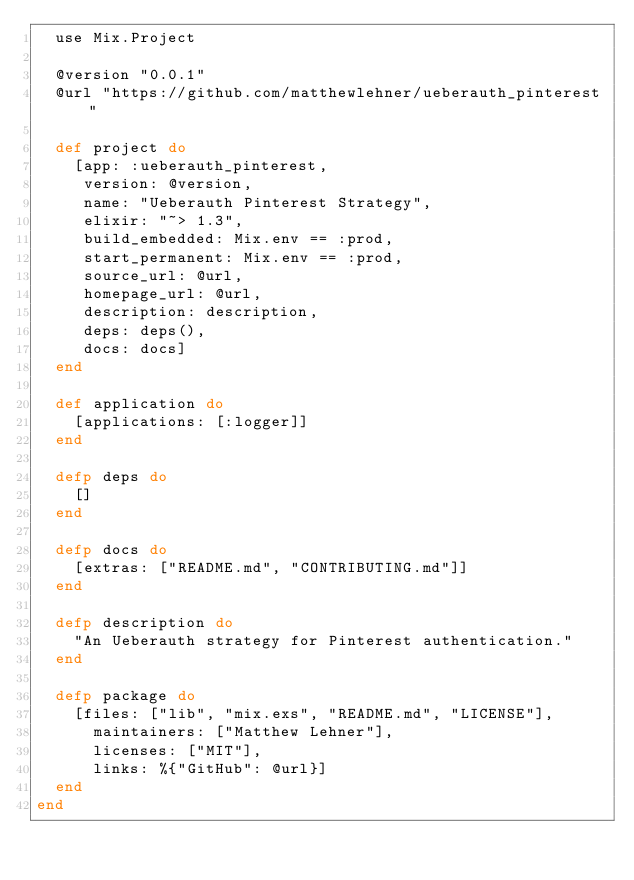Convert code to text. <code><loc_0><loc_0><loc_500><loc_500><_Elixir_>  use Mix.Project

  @version "0.0.1"
  @url "https://github.com/matthewlehner/ueberauth_pinterest"

  def project do
    [app: :ueberauth_pinterest,
     version: @version,
     name: "Ueberauth Pinterest Strategy",
     elixir: "~> 1.3",
     build_embedded: Mix.env == :prod,
     start_permanent: Mix.env == :prod,
     source_url: @url,
     homepage_url: @url,
     description: description,
     deps: deps(),
     docs: docs]
  end

  def application do
    [applications: [:logger]]
  end

  defp deps do
    []
  end

  defp docs do
    [extras: ["README.md", "CONTRIBUTING.md"]]
  end

  defp description do
    "An Ueberauth strategy for Pinterest authentication."
  end

  defp package do
    [files: ["lib", "mix.exs", "README.md", "LICENSE"],
      maintainers: ["Matthew Lehner"],
      licenses: ["MIT"],
      links: %{"GitHub": @url}]
  end
end
</code> 